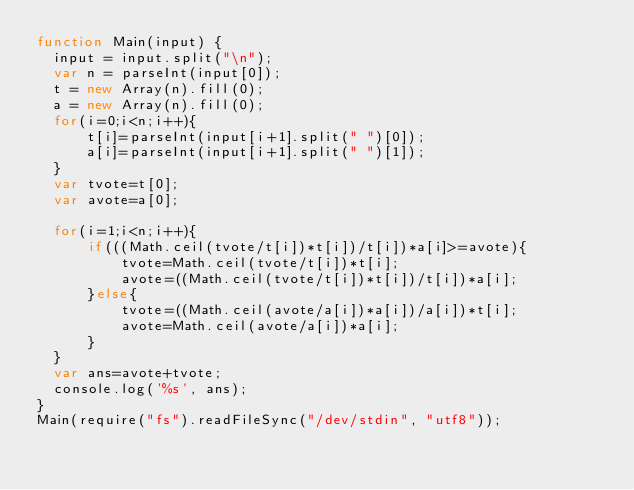Convert code to text. <code><loc_0><loc_0><loc_500><loc_500><_JavaScript_>function Main(input) {
  input = input.split("\n");
  var n = parseInt(input[0]);
  t = new Array(n).fill(0);
  a = new Array(n).fill(0);
  for(i=0;i<n;i++){
      t[i]=parseInt(input[i+1].split(" ")[0]);
      a[i]=parseInt(input[i+1].split(" ")[1]);
  }
  var tvote=t[0];
  var avote=a[0];
  
  for(i=1;i<n;i++){
      if(((Math.ceil(tvote/t[i])*t[i])/t[i])*a[i]>=avote){
          tvote=Math.ceil(tvote/t[i])*t[i];
          avote=((Math.ceil(tvote/t[i])*t[i])/t[i])*a[i];
      }else{
          tvote=((Math.ceil(avote/a[i])*a[i])/a[i])*t[i];
          avote=Math.ceil(avote/a[i])*a[i];
      }
  }
  var ans=avote+tvote;
  console.log('%s', ans);
}
Main(require("fs").readFileSync("/dev/stdin", "utf8"));</code> 